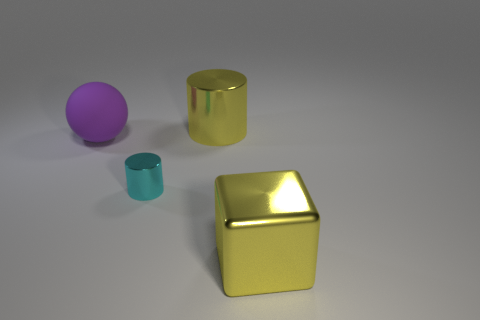Add 1 green metal cylinders. How many objects exist? 5 Subtract all spheres. How many objects are left? 3 Add 4 large metal cylinders. How many large metal cylinders are left? 5 Add 3 tiny green cylinders. How many tiny green cylinders exist? 3 Subtract 0 green cylinders. How many objects are left? 4 Subtract all large purple objects. Subtract all big green rubber cylinders. How many objects are left? 3 